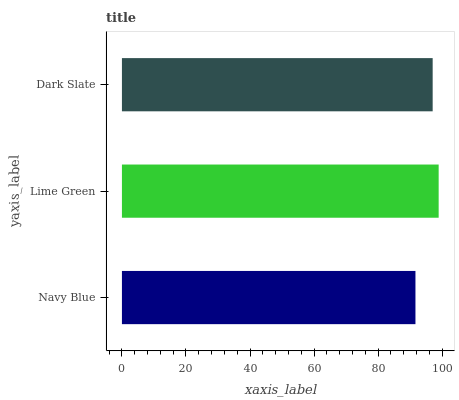Is Navy Blue the minimum?
Answer yes or no. Yes. Is Lime Green the maximum?
Answer yes or no. Yes. Is Dark Slate the minimum?
Answer yes or no. No. Is Dark Slate the maximum?
Answer yes or no. No. Is Lime Green greater than Dark Slate?
Answer yes or no. Yes. Is Dark Slate less than Lime Green?
Answer yes or no. Yes. Is Dark Slate greater than Lime Green?
Answer yes or no. No. Is Lime Green less than Dark Slate?
Answer yes or no. No. Is Dark Slate the high median?
Answer yes or no. Yes. Is Dark Slate the low median?
Answer yes or no. Yes. Is Lime Green the high median?
Answer yes or no. No. Is Navy Blue the low median?
Answer yes or no. No. 